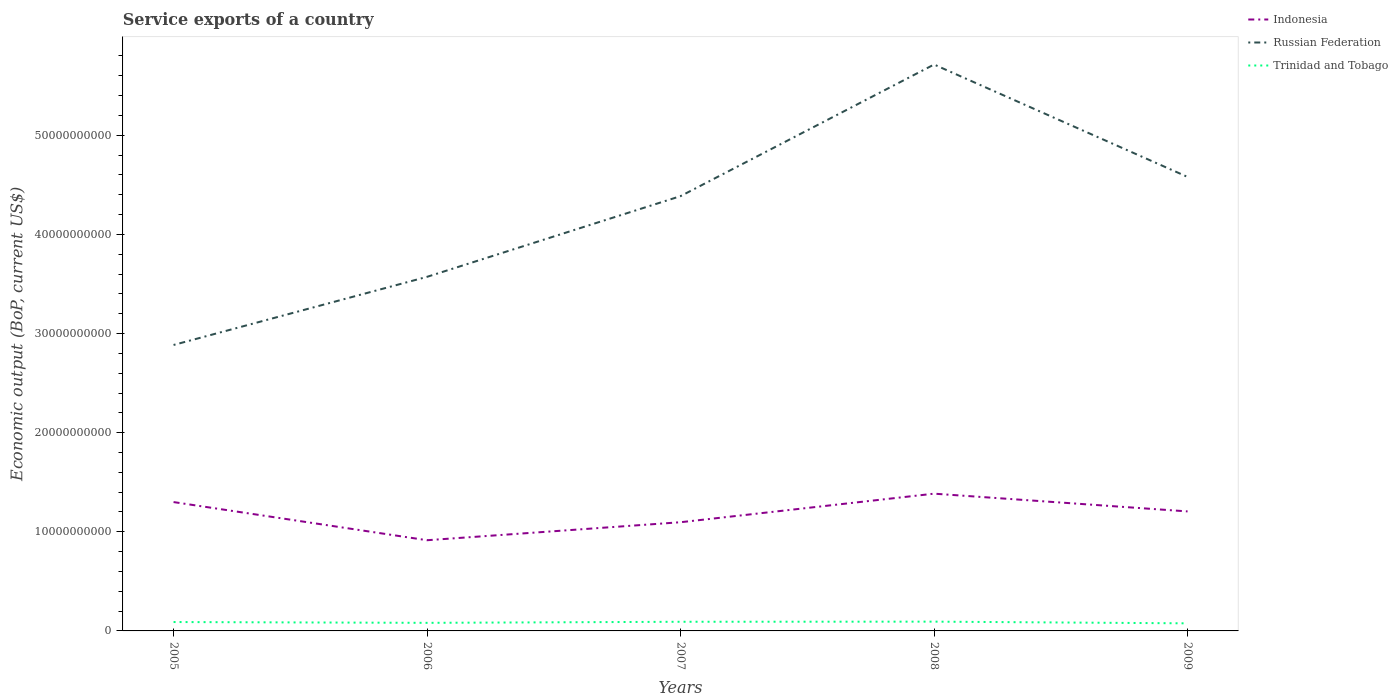How many different coloured lines are there?
Offer a terse response. 3. Does the line corresponding to Russian Federation intersect with the line corresponding to Indonesia?
Offer a terse response. No. Is the number of lines equal to the number of legend labels?
Keep it short and to the point. Yes. Across all years, what is the maximum service exports in Russian Federation?
Ensure brevity in your answer.  2.88e+1. What is the total service exports in Trinidad and Tobago in the graph?
Give a very brief answer. 8.21e+07. What is the difference between the highest and the second highest service exports in Indonesia?
Offer a terse response. 4.70e+09. What is the difference between the highest and the lowest service exports in Trinidad and Tobago?
Give a very brief answer. 3. Is the service exports in Trinidad and Tobago strictly greater than the service exports in Indonesia over the years?
Ensure brevity in your answer.  Yes. Does the graph contain any zero values?
Your answer should be very brief. No. Where does the legend appear in the graph?
Ensure brevity in your answer.  Top right. How are the legend labels stacked?
Ensure brevity in your answer.  Vertical. What is the title of the graph?
Provide a succinct answer. Service exports of a country. Does "Heavily indebted poor countries" appear as one of the legend labels in the graph?
Make the answer very short. No. What is the label or title of the X-axis?
Keep it short and to the point. Years. What is the label or title of the Y-axis?
Offer a terse response. Economic output (BoP, current US$). What is the Economic output (BoP, current US$) in Indonesia in 2005?
Your response must be concise. 1.30e+1. What is the Economic output (BoP, current US$) of Russian Federation in 2005?
Provide a short and direct response. 2.88e+1. What is the Economic output (BoP, current US$) in Trinidad and Tobago in 2005?
Give a very brief answer. 8.97e+08. What is the Economic output (BoP, current US$) in Indonesia in 2006?
Provide a short and direct response. 9.15e+09. What is the Economic output (BoP, current US$) of Russian Federation in 2006?
Your answer should be very brief. 3.57e+1. What is the Economic output (BoP, current US$) of Trinidad and Tobago in 2006?
Give a very brief answer. 8.15e+08. What is the Economic output (BoP, current US$) in Indonesia in 2007?
Provide a short and direct response. 1.10e+1. What is the Economic output (BoP, current US$) of Russian Federation in 2007?
Your response must be concise. 4.39e+1. What is the Economic output (BoP, current US$) of Trinidad and Tobago in 2007?
Offer a terse response. 9.24e+08. What is the Economic output (BoP, current US$) in Indonesia in 2008?
Your answer should be very brief. 1.38e+1. What is the Economic output (BoP, current US$) of Russian Federation in 2008?
Your response must be concise. 5.71e+1. What is the Economic output (BoP, current US$) of Trinidad and Tobago in 2008?
Ensure brevity in your answer.  9.36e+08. What is the Economic output (BoP, current US$) of Indonesia in 2009?
Give a very brief answer. 1.21e+1. What is the Economic output (BoP, current US$) of Russian Federation in 2009?
Provide a short and direct response. 4.58e+1. What is the Economic output (BoP, current US$) in Trinidad and Tobago in 2009?
Provide a succinct answer. 7.65e+08. Across all years, what is the maximum Economic output (BoP, current US$) of Indonesia?
Your response must be concise. 1.38e+1. Across all years, what is the maximum Economic output (BoP, current US$) in Russian Federation?
Your response must be concise. 5.71e+1. Across all years, what is the maximum Economic output (BoP, current US$) in Trinidad and Tobago?
Give a very brief answer. 9.36e+08. Across all years, what is the minimum Economic output (BoP, current US$) in Indonesia?
Provide a succinct answer. 9.15e+09. Across all years, what is the minimum Economic output (BoP, current US$) of Russian Federation?
Keep it short and to the point. 2.88e+1. Across all years, what is the minimum Economic output (BoP, current US$) in Trinidad and Tobago?
Offer a very short reply. 7.65e+08. What is the total Economic output (BoP, current US$) of Indonesia in the graph?
Make the answer very short. 5.90e+1. What is the total Economic output (BoP, current US$) in Russian Federation in the graph?
Give a very brief answer. 2.11e+11. What is the total Economic output (BoP, current US$) in Trinidad and Tobago in the graph?
Ensure brevity in your answer.  4.34e+09. What is the difference between the Economic output (BoP, current US$) of Indonesia in 2005 and that in 2006?
Provide a succinct answer. 3.85e+09. What is the difference between the Economic output (BoP, current US$) in Russian Federation in 2005 and that in 2006?
Your response must be concise. -6.87e+09. What is the difference between the Economic output (BoP, current US$) in Trinidad and Tobago in 2005 and that in 2006?
Ensure brevity in your answer.  8.21e+07. What is the difference between the Economic output (BoP, current US$) of Indonesia in 2005 and that in 2007?
Your answer should be very brief. 2.03e+09. What is the difference between the Economic output (BoP, current US$) of Russian Federation in 2005 and that in 2007?
Offer a terse response. -1.50e+1. What is the difference between the Economic output (BoP, current US$) in Trinidad and Tobago in 2005 and that in 2007?
Your response must be concise. -2.69e+07. What is the difference between the Economic output (BoP, current US$) of Indonesia in 2005 and that in 2008?
Offer a terse response. -8.48e+08. What is the difference between the Economic output (BoP, current US$) in Russian Federation in 2005 and that in 2008?
Your response must be concise. -2.83e+1. What is the difference between the Economic output (BoP, current US$) of Trinidad and Tobago in 2005 and that in 2008?
Your answer should be very brief. -3.96e+07. What is the difference between the Economic output (BoP, current US$) in Indonesia in 2005 and that in 2009?
Your answer should be very brief. 9.42e+08. What is the difference between the Economic output (BoP, current US$) of Russian Federation in 2005 and that in 2009?
Offer a very short reply. -1.70e+1. What is the difference between the Economic output (BoP, current US$) in Trinidad and Tobago in 2005 and that in 2009?
Your answer should be very brief. 1.32e+08. What is the difference between the Economic output (BoP, current US$) in Indonesia in 2006 and that in 2007?
Your response must be concise. -1.82e+09. What is the difference between the Economic output (BoP, current US$) in Russian Federation in 2006 and that in 2007?
Give a very brief answer. -8.14e+09. What is the difference between the Economic output (BoP, current US$) in Trinidad and Tobago in 2006 and that in 2007?
Ensure brevity in your answer.  -1.09e+08. What is the difference between the Economic output (BoP, current US$) of Indonesia in 2006 and that in 2008?
Offer a terse response. -4.70e+09. What is the difference between the Economic output (BoP, current US$) in Russian Federation in 2006 and that in 2008?
Provide a succinct answer. -2.14e+1. What is the difference between the Economic output (BoP, current US$) of Trinidad and Tobago in 2006 and that in 2008?
Ensure brevity in your answer.  -1.22e+08. What is the difference between the Economic output (BoP, current US$) of Indonesia in 2006 and that in 2009?
Provide a short and direct response. -2.91e+09. What is the difference between the Economic output (BoP, current US$) of Russian Federation in 2006 and that in 2009?
Provide a short and direct response. -1.01e+1. What is the difference between the Economic output (BoP, current US$) of Indonesia in 2007 and that in 2008?
Provide a succinct answer. -2.88e+09. What is the difference between the Economic output (BoP, current US$) of Russian Federation in 2007 and that in 2008?
Offer a terse response. -1.33e+1. What is the difference between the Economic output (BoP, current US$) of Trinidad and Tobago in 2007 and that in 2008?
Provide a short and direct response. -1.27e+07. What is the difference between the Economic output (BoP, current US$) in Indonesia in 2007 and that in 2009?
Offer a terse response. -1.09e+09. What is the difference between the Economic output (BoP, current US$) in Russian Federation in 2007 and that in 2009?
Provide a succinct answer. -1.94e+09. What is the difference between the Economic output (BoP, current US$) of Trinidad and Tobago in 2007 and that in 2009?
Ensure brevity in your answer.  1.59e+08. What is the difference between the Economic output (BoP, current US$) of Indonesia in 2008 and that in 2009?
Give a very brief answer. 1.79e+09. What is the difference between the Economic output (BoP, current US$) in Russian Federation in 2008 and that in 2009?
Offer a terse response. 1.13e+1. What is the difference between the Economic output (BoP, current US$) in Trinidad and Tobago in 2008 and that in 2009?
Keep it short and to the point. 1.72e+08. What is the difference between the Economic output (BoP, current US$) of Indonesia in 2005 and the Economic output (BoP, current US$) of Russian Federation in 2006?
Offer a terse response. -2.27e+1. What is the difference between the Economic output (BoP, current US$) of Indonesia in 2005 and the Economic output (BoP, current US$) of Trinidad and Tobago in 2006?
Your response must be concise. 1.22e+1. What is the difference between the Economic output (BoP, current US$) in Russian Federation in 2005 and the Economic output (BoP, current US$) in Trinidad and Tobago in 2006?
Offer a terse response. 2.80e+1. What is the difference between the Economic output (BoP, current US$) of Indonesia in 2005 and the Economic output (BoP, current US$) of Russian Federation in 2007?
Your answer should be compact. -3.09e+1. What is the difference between the Economic output (BoP, current US$) of Indonesia in 2005 and the Economic output (BoP, current US$) of Trinidad and Tobago in 2007?
Offer a very short reply. 1.21e+1. What is the difference between the Economic output (BoP, current US$) in Russian Federation in 2005 and the Economic output (BoP, current US$) in Trinidad and Tobago in 2007?
Provide a short and direct response. 2.79e+1. What is the difference between the Economic output (BoP, current US$) of Indonesia in 2005 and the Economic output (BoP, current US$) of Russian Federation in 2008?
Offer a very short reply. -4.41e+1. What is the difference between the Economic output (BoP, current US$) in Indonesia in 2005 and the Economic output (BoP, current US$) in Trinidad and Tobago in 2008?
Your answer should be very brief. 1.21e+1. What is the difference between the Economic output (BoP, current US$) of Russian Federation in 2005 and the Economic output (BoP, current US$) of Trinidad and Tobago in 2008?
Make the answer very short. 2.79e+1. What is the difference between the Economic output (BoP, current US$) of Indonesia in 2005 and the Economic output (BoP, current US$) of Russian Federation in 2009?
Provide a short and direct response. -3.28e+1. What is the difference between the Economic output (BoP, current US$) of Indonesia in 2005 and the Economic output (BoP, current US$) of Trinidad and Tobago in 2009?
Your response must be concise. 1.22e+1. What is the difference between the Economic output (BoP, current US$) in Russian Federation in 2005 and the Economic output (BoP, current US$) in Trinidad and Tobago in 2009?
Keep it short and to the point. 2.81e+1. What is the difference between the Economic output (BoP, current US$) of Indonesia in 2006 and the Economic output (BoP, current US$) of Russian Federation in 2007?
Give a very brief answer. -3.47e+1. What is the difference between the Economic output (BoP, current US$) of Indonesia in 2006 and the Economic output (BoP, current US$) of Trinidad and Tobago in 2007?
Ensure brevity in your answer.  8.23e+09. What is the difference between the Economic output (BoP, current US$) in Russian Federation in 2006 and the Economic output (BoP, current US$) in Trinidad and Tobago in 2007?
Offer a very short reply. 3.48e+1. What is the difference between the Economic output (BoP, current US$) in Indonesia in 2006 and the Economic output (BoP, current US$) in Russian Federation in 2008?
Keep it short and to the point. -4.80e+1. What is the difference between the Economic output (BoP, current US$) of Indonesia in 2006 and the Economic output (BoP, current US$) of Trinidad and Tobago in 2008?
Offer a terse response. 8.21e+09. What is the difference between the Economic output (BoP, current US$) in Russian Federation in 2006 and the Economic output (BoP, current US$) in Trinidad and Tobago in 2008?
Your answer should be very brief. 3.48e+1. What is the difference between the Economic output (BoP, current US$) in Indonesia in 2006 and the Economic output (BoP, current US$) in Russian Federation in 2009?
Your answer should be compact. -3.66e+1. What is the difference between the Economic output (BoP, current US$) of Indonesia in 2006 and the Economic output (BoP, current US$) of Trinidad and Tobago in 2009?
Your response must be concise. 8.38e+09. What is the difference between the Economic output (BoP, current US$) in Russian Federation in 2006 and the Economic output (BoP, current US$) in Trinidad and Tobago in 2009?
Provide a short and direct response. 3.50e+1. What is the difference between the Economic output (BoP, current US$) in Indonesia in 2007 and the Economic output (BoP, current US$) in Russian Federation in 2008?
Offer a terse response. -4.62e+1. What is the difference between the Economic output (BoP, current US$) of Indonesia in 2007 and the Economic output (BoP, current US$) of Trinidad and Tobago in 2008?
Your answer should be compact. 1.00e+1. What is the difference between the Economic output (BoP, current US$) of Russian Federation in 2007 and the Economic output (BoP, current US$) of Trinidad and Tobago in 2008?
Your response must be concise. 4.29e+1. What is the difference between the Economic output (BoP, current US$) in Indonesia in 2007 and the Economic output (BoP, current US$) in Russian Federation in 2009?
Offer a very short reply. -3.48e+1. What is the difference between the Economic output (BoP, current US$) in Indonesia in 2007 and the Economic output (BoP, current US$) in Trinidad and Tobago in 2009?
Give a very brief answer. 1.02e+1. What is the difference between the Economic output (BoP, current US$) of Russian Federation in 2007 and the Economic output (BoP, current US$) of Trinidad and Tobago in 2009?
Your response must be concise. 4.31e+1. What is the difference between the Economic output (BoP, current US$) of Indonesia in 2008 and the Economic output (BoP, current US$) of Russian Federation in 2009?
Make the answer very short. -3.20e+1. What is the difference between the Economic output (BoP, current US$) of Indonesia in 2008 and the Economic output (BoP, current US$) of Trinidad and Tobago in 2009?
Provide a succinct answer. 1.31e+1. What is the difference between the Economic output (BoP, current US$) of Russian Federation in 2008 and the Economic output (BoP, current US$) of Trinidad and Tobago in 2009?
Offer a very short reply. 5.64e+1. What is the average Economic output (BoP, current US$) of Indonesia per year?
Give a very brief answer. 1.18e+1. What is the average Economic output (BoP, current US$) in Russian Federation per year?
Keep it short and to the point. 4.23e+1. What is the average Economic output (BoP, current US$) in Trinidad and Tobago per year?
Keep it short and to the point. 8.67e+08. In the year 2005, what is the difference between the Economic output (BoP, current US$) in Indonesia and Economic output (BoP, current US$) in Russian Federation?
Ensure brevity in your answer.  -1.58e+1. In the year 2005, what is the difference between the Economic output (BoP, current US$) in Indonesia and Economic output (BoP, current US$) in Trinidad and Tobago?
Ensure brevity in your answer.  1.21e+1. In the year 2005, what is the difference between the Economic output (BoP, current US$) in Russian Federation and Economic output (BoP, current US$) in Trinidad and Tobago?
Your response must be concise. 2.79e+1. In the year 2006, what is the difference between the Economic output (BoP, current US$) of Indonesia and Economic output (BoP, current US$) of Russian Federation?
Make the answer very short. -2.66e+1. In the year 2006, what is the difference between the Economic output (BoP, current US$) in Indonesia and Economic output (BoP, current US$) in Trinidad and Tobago?
Ensure brevity in your answer.  8.33e+09. In the year 2006, what is the difference between the Economic output (BoP, current US$) in Russian Federation and Economic output (BoP, current US$) in Trinidad and Tobago?
Offer a terse response. 3.49e+1. In the year 2007, what is the difference between the Economic output (BoP, current US$) of Indonesia and Economic output (BoP, current US$) of Russian Federation?
Keep it short and to the point. -3.29e+1. In the year 2007, what is the difference between the Economic output (BoP, current US$) in Indonesia and Economic output (BoP, current US$) in Trinidad and Tobago?
Keep it short and to the point. 1.00e+1. In the year 2007, what is the difference between the Economic output (BoP, current US$) of Russian Federation and Economic output (BoP, current US$) of Trinidad and Tobago?
Provide a short and direct response. 4.29e+1. In the year 2008, what is the difference between the Economic output (BoP, current US$) in Indonesia and Economic output (BoP, current US$) in Russian Federation?
Your answer should be compact. -4.33e+1. In the year 2008, what is the difference between the Economic output (BoP, current US$) in Indonesia and Economic output (BoP, current US$) in Trinidad and Tobago?
Your answer should be very brief. 1.29e+1. In the year 2008, what is the difference between the Economic output (BoP, current US$) of Russian Federation and Economic output (BoP, current US$) of Trinidad and Tobago?
Ensure brevity in your answer.  5.62e+1. In the year 2009, what is the difference between the Economic output (BoP, current US$) of Indonesia and Economic output (BoP, current US$) of Russian Federation?
Your answer should be compact. -3.37e+1. In the year 2009, what is the difference between the Economic output (BoP, current US$) in Indonesia and Economic output (BoP, current US$) in Trinidad and Tobago?
Your answer should be very brief. 1.13e+1. In the year 2009, what is the difference between the Economic output (BoP, current US$) of Russian Federation and Economic output (BoP, current US$) of Trinidad and Tobago?
Keep it short and to the point. 4.50e+1. What is the ratio of the Economic output (BoP, current US$) in Indonesia in 2005 to that in 2006?
Make the answer very short. 1.42. What is the ratio of the Economic output (BoP, current US$) of Russian Federation in 2005 to that in 2006?
Your answer should be compact. 0.81. What is the ratio of the Economic output (BoP, current US$) in Trinidad and Tobago in 2005 to that in 2006?
Your answer should be compact. 1.1. What is the ratio of the Economic output (BoP, current US$) of Indonesia in 2005 to that in 2007?
Provide a succinct answer. 1.19. What is the ratio of the Economic output (BoP, current US$) in Russian Federation in 2005 to that in 2007?
Your response must be concise. 0.66. What is the ratio of the Economic output (BoP, current US$) in Trinidad and Tobago in 2005 to that in 2007?
Provide a short and direct response. 0.97. What is the ratio of the Economic output (BoP, current US$) in Indonesia in 2005 to that in 2008?
Offer a very short reply. 0.94. What is the ratio of the Economic output (BoP, current US$) of Russian Federation in 2005 to that in 2008?
Keep it short and to the point. 0.5. What is the ratio of the Economic output (BoP, current US$) of Trinidad and Tobago in 2005 to that in 2008?
Keep it short and to the point. 0.96. What is the ratio of the Economic output (BoP, current US$) in Indonesia in 2005 to that in 2009?
Offer a very short reply. 1.08. What is the ratio of the Economic output (BoP, current US$) in Russian Federation in 2005 to that in 2009?
Ensure brevity in your answer.  0.63. What is the ratio of the Economic output (BoP, current US$) in Trinidad and Tobago in 2005 to that in 2009?
Ensure brevity in your answer.  1.17. What is the ratio of the Economic output (BoP, current US$) of Indonesia in 2006 to that in 2007?
Ensure brevity in your answer.  0.83. What is the ratio of the Economic output (BoP, current US$) of Russian Federation in 2006 to that in 2007?
Offer a very short reply. 0.81. What is the ratio of the Economic output (BoP, current US$) of Trinidad and Tobago in 2006 to that in 2007?
Provide a succinct answer. 0.88. What is the ratio of the Economic output (BoP, current US$) in Indonesia in 2006 to that in 2008?
Provide a short and direct response. 0.66. What is the ratio of the Economic output (BoP, current US$) of Russian Federation in 2006 to that in 2008?
Offer a terse response. 0.63. What is the ratio of the Economic output (BoP, current US$) in Trinidad and Tobago in 2006 to that in 2008?
Offer a terse response. 0.87. What is the ratio of the Economic output (BoP, current US$) of Indonesia in 2006 to that in 2009?
Offer a very short reply. 0.76. What is the ratio of the Economic output (BoP, current US$) in Russian Federation in 2006 to that in 2009?
Your answer should be very brief. 0.78. What is the ratio of the Economic output (BoP, current US$) of Trinidad and Tobago in 2006 to that in 2009?
Keep it short and to the point. 1.07. What is the ratio of the Economic output (BoP, current US$) in Indonesia in 2007 to that in 2008?
Offer a very short reply. 0.79. What is the ratio of the Economic output (BoP, current US$) in Russian Federation in 2007 to that in 2008?
Your answer should be very brief. 0.77. What is the ratio of the Economic output (BoP, current US$) in Trinidad and Tobago in 2007 to that in 2008?
Offer a very short reply. 0.99. What is the ratio of the Economic output (BoP, current US$) of Indonesia in 2007 to that in 2009?
Your answer should be very brief. 0.91. What is the ratio of the Economic output (BoP, current US$) of Russian Federation in 2007 to that in 2009?
Ensure brevity in your answer.  0.96. What is the ratio of the Economic output (BoP, current US$) in Trinidad and Tobago in 2007 to that in 2009?
Your response must be concise. 1.21. What is the ratio of the Economic output (BoP, current US$) of Indonesia in 2008 to that in 2009?
Your response must be concise. 1.15. What is the ratio of the Economic output (BoP, current US$) in Russian Federation in 2008 to that in 2009?
Give a very brief answer. 1.25. What is the ratio of the Economic output (BoP, current US$) in Trinidad and Tobago in 2008 to that in 2009?
Offer a very short reply. 1.22. What is the difference between the highest and the second highest Economic output (BoP, current US$) in Indonesia?
Offer a very short reply. 8.48e+08. What is the difference between the highest and the second highest Economic output (BoP, current US$) in Russian Federation?
Provide a short and direct response. 1.13e+1. What is the difference between the highest and the second highest Economic output (BoP, current US$) of Trinidad and Tobago?
Offer a terse response. 1.27e+07. What is the difference between the highest and the lowest Economic output (BoP, current US$) in Indonesia?
Keep it short and to the point. 4.70e+09. What is the difference between the highest and the lowest Economic output (BoP, current US$) of Russian Federation?
Offer a terse response. 2.83e+1. What is the difference between the highest and the lowest Economic output (BoP, current US$) of Trinidad and Tobago?
Offer a very short reply. 1.72e+08. 